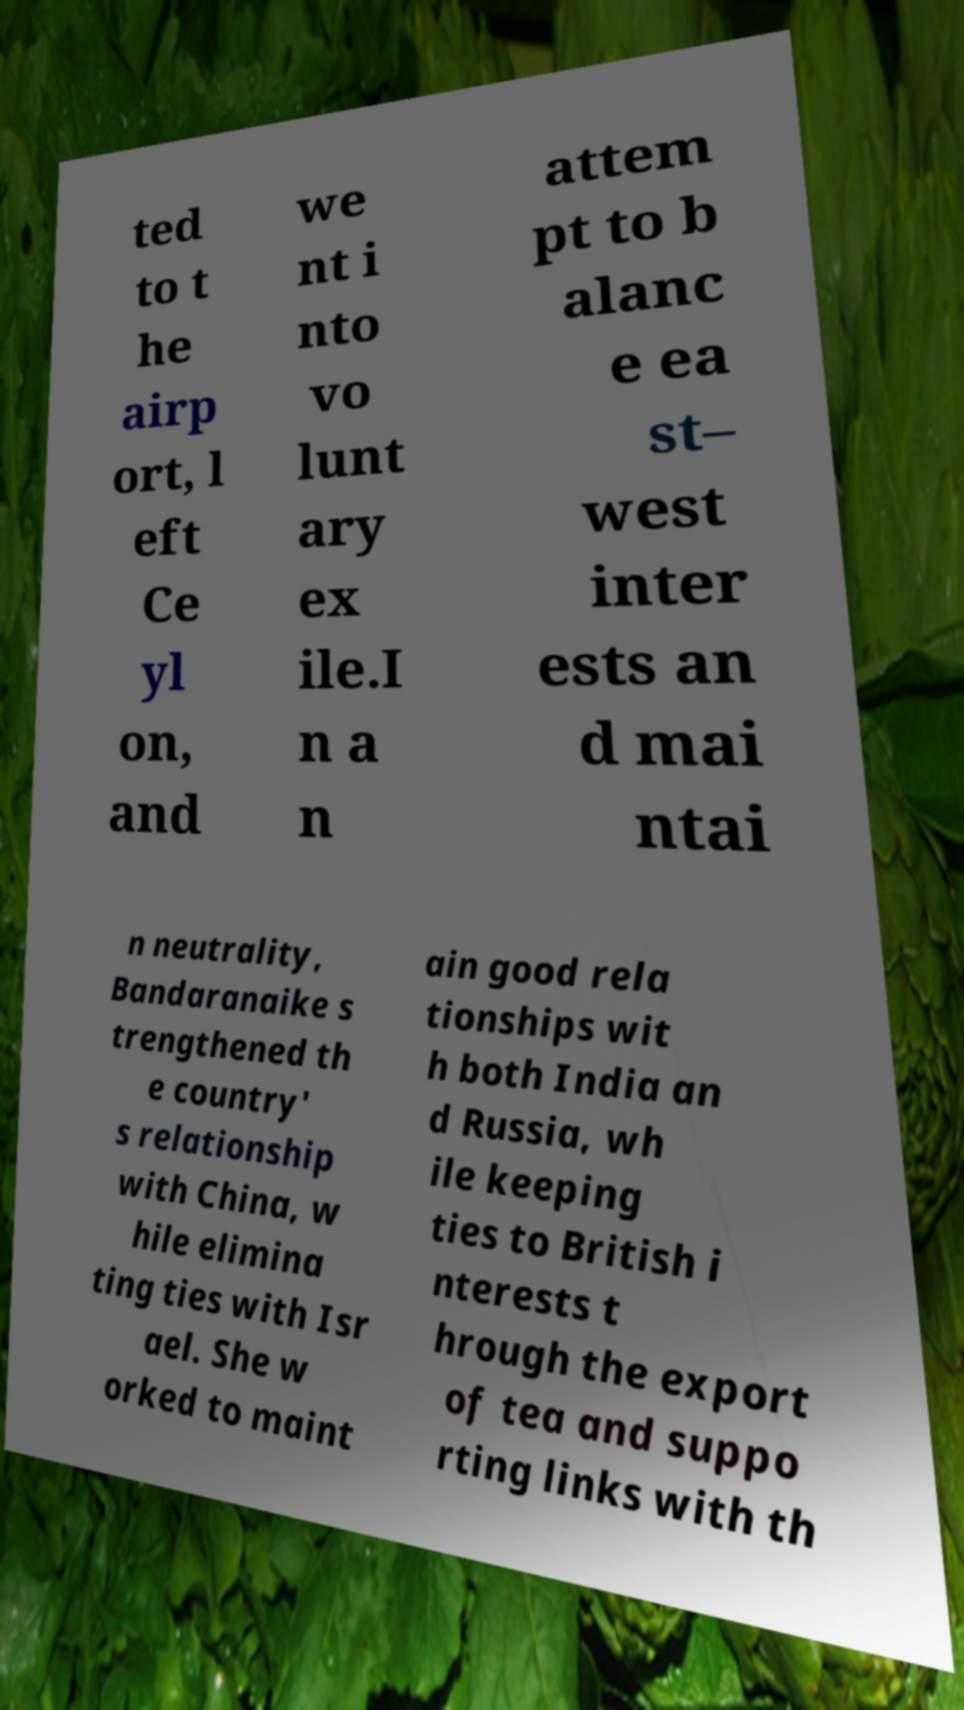What messages or text are displayed in this image? I need them in a readable, typed format. ted to t he airp ort, l eft Ce yl on, and we nt i nto vo lunt ary ex ile.I n a n attem pt to b alanc e ea st– west inter ests an d mai ntai n neutrality, Bandaranaike s trengthened th e country' s relationship with China, w hile elimina ting ties with Isr ael. She w orked to maint ain good rela tionships wit h both India an d Russia, wh ile keeping ties to British i nterests t hrough the export of tea and suppo rting links with th 